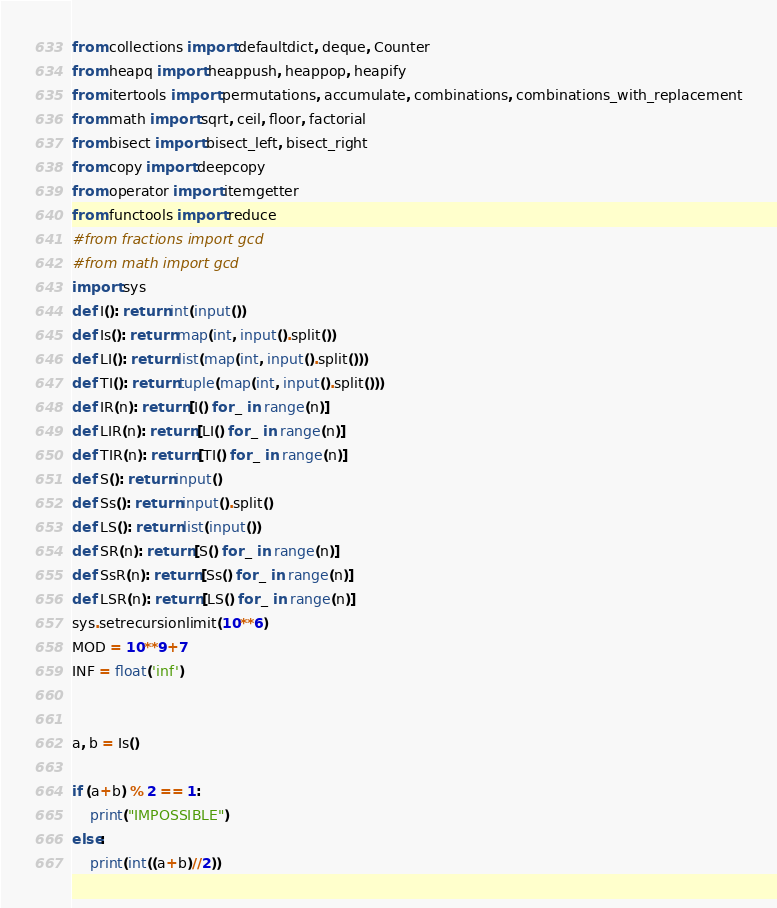Convert code to text. <code><loc_0><loc_0><loc_500><loc_500><_Python_>from collections import defaultdict, deque, Counter
from heapq import heappush, heappop, heapify
from itertools import permutations, accumulate, combinations, combinations_with_replacement
from math import sqrt, ceil, floor, factorial
from bisect import bisect_left, bisect_right
from copy import deepcopy
from operator import itemgetter
from functools import reduce
#from fractions import gcd
#from math import gcd
import sys
def I(): return int(input())
def Is(): return map(int, input().split())
def LI(): return list(map(int, input().split()))
def TI(): return tuple(map(int, input().split()))
def IR(n): return [I() for _ in range(n)]
def LIR(n): return [LI() for _ in range(n)]
def TIR(n): return [TI() for _ in range(n)]
def S(): return input()
def Ss(): return input().split()
def LS(): return list(input())
def SR(n): return [S() for _ in range(n)]
def SsR(n): return [Ss() for _ in range(n)]
def LSR(n): return [LS() for _ in range(n)]
sys.setrecursionlimit(10**6)
MOD = 10**9+7
INF = float('inf')


a, b = Is()

if (a+b) % 2 == 1:
    print("IMPOSSIBLE")
else:
    print(int((a+b)//2))</code> 